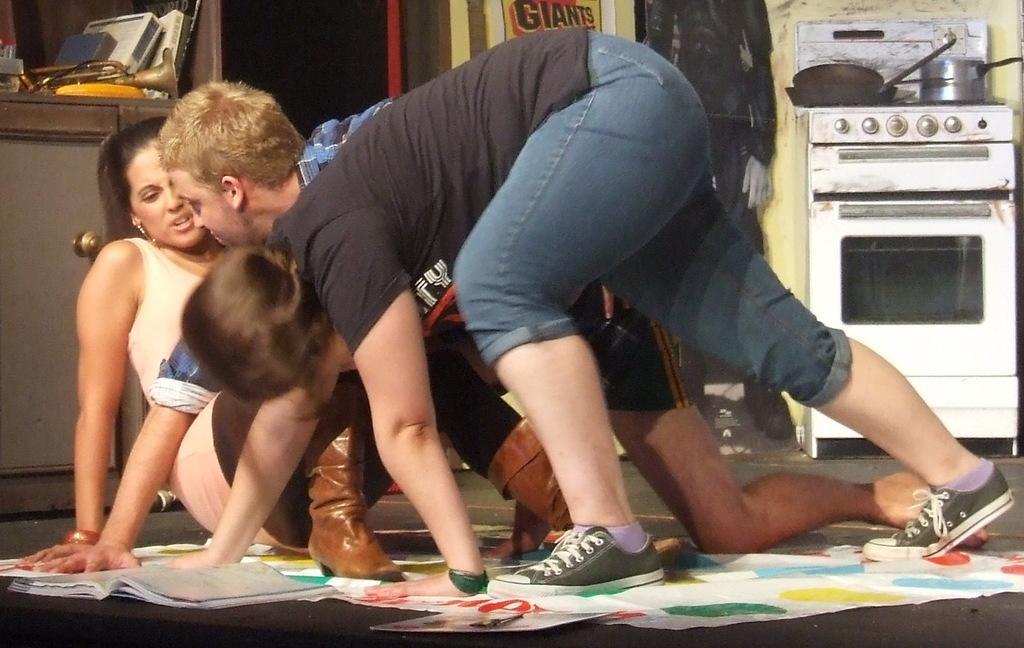Describe this image in one or two sentences. In this image I can see a person wearing black t shirt and blue jeans is bending on the floor. On the floor I can see a book and I can see few other persons bending and sitting on the floor. In the background I can see a oven which is white in color, a gas stove, few bowls on the gas stove, a musical instrument and few other objects. 